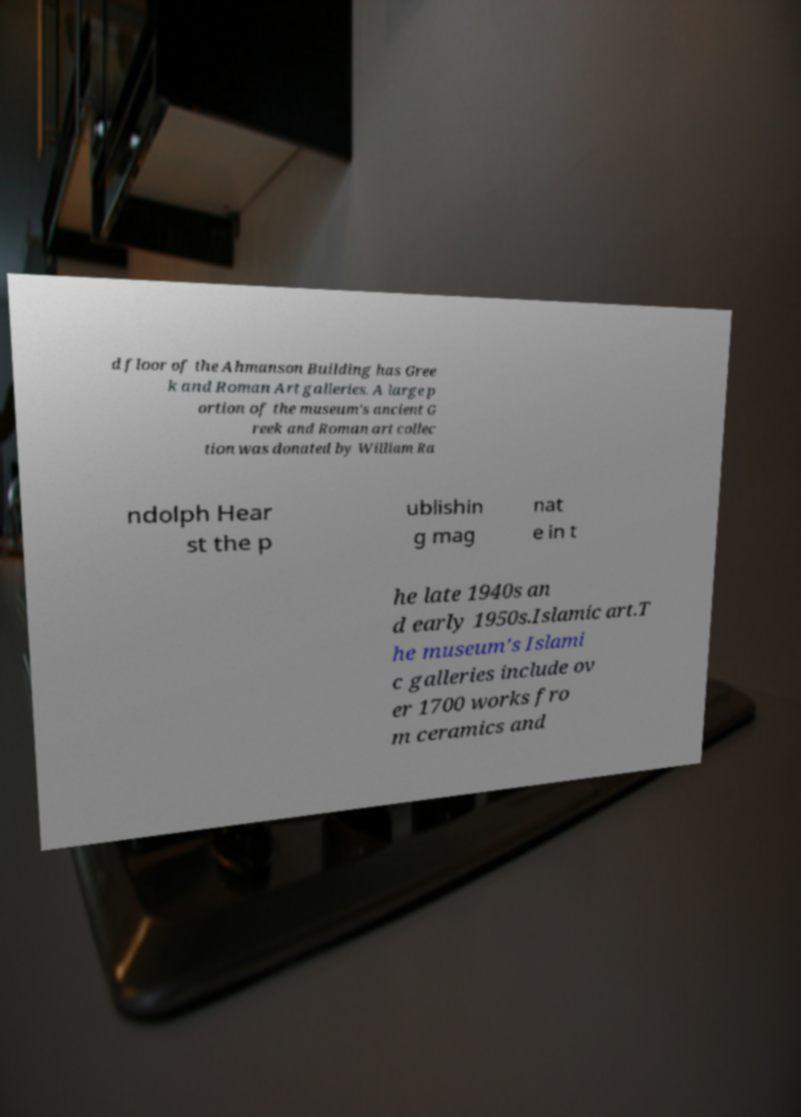Could you assist in decoding the text presented in this image and type it out clearly? d floor of the Ahmanson Building has Gree k and Roman Art galleries. A large p ortion of the museum's ancient G reek and Roman art collec tion was donated by William Ra ndolph Hear st the p ublishin g mag nat e in t he late 1940s an d early 1950s.Islamic art.T he museum's Islami c galleries include ov er 1700 works fro m ceramics and 